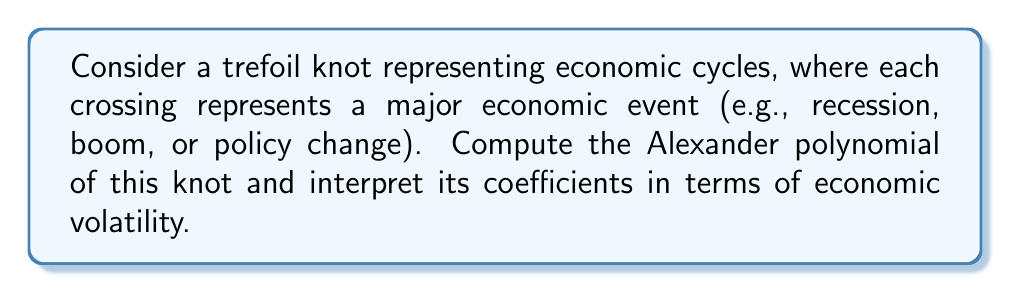Give your solution to this math problem. To compute the Alexander polynomial of the trefoil knot and interpret it in economic terms, we'll follow these steps:

1. Draw the trefoil knot diagram:
[asy]
import geometry;

pair A = (0,1), B = (0.866,-0.5), C = (-0.866,-0.5);
draw(A--B--C--cycle);
draw(A--(0.433,0.25)--(0,-0.5)--(-0.433,0.25)--cycle);
dot(A); dot(B); dot(C);
label("1", A, N);
label("2", B, SE);
label("3", C, SW);
[/asy]

2. Label the arcs and crossings:
   - Arcs: 1, 2, 3
   - Crossings: a, b, c

3. Create the Alexander matrix:
   $$\begin{pmatrix}
   1-t & -1 & t \\
   t & 1-t & -1 \\
   -1 & t & 1-t
   \end{pmatrix}$$

4. Calculate the determinant of any 2x2 minor:
   Let's use the minor formed by removing the first row and column:
   $$\Delta(t) = \begin{vmatrix}
   1-t & -1 \\
   t & 1-t
   \end{vmatrix}$$

5. Expand the determinant:
   $$\Delta(t) = (1-t)(1-t) - (-1)(t)$$
   $$\Delta(t) = 1 - 2t + t^2 + t$$
   $$\Delta(t) = 1 - t + t^2$$

6. Interpret the coefficients:
   - Constant term (1): Represents the baseline economic state
   - Linear term (-t): Indicates a tendency towards economic instability
   - Quadratic term (t^2): Suggests the presence of cyclical patterns

In economic terms, the Alexander polynomial $\Delta(t) = 1 - t + t^2$ can be interpreted as follows:
- The negative linear term (-t) suggests that the economy tends to deviate from its baseline state.
- The positive quadratic term (t^2) indicates that there are forces pushing the economy back towards equilibrium, creating cyclical behavior.
- The combination of these terms represents the push and pull of economic forces, resulting in economic cycles.

The economist studying stimulus checks could use this polynomial to model how interventions like stimulus payments might affect the amplitude or frequency of these economic cycles.
Answer: $\Delta(t) = 1 - t + t^2$ 